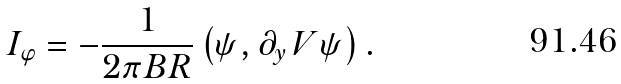<formula> <loc_0><loc_0><loc_500><loc_500>I _ { \varphi } = - \frac { 1 } { 2 \pi B R } \left ( \psi , \partial _ { y } \, V \psi \right ) .</formula> 